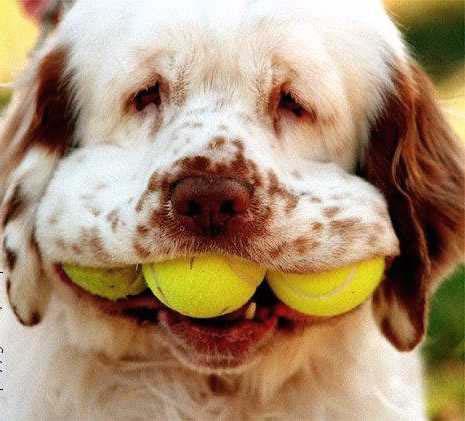How many teeth can you see?
Concise answer only. 1. What type of balls are in the dog's mouth?
Give a very brief answer. Tennis. How many balls does this dog have in its mouth?
Write a very short answer. 3. 